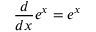<formula> <loc_0><loc_0><loc_500><loc_500>{ \frac { d } { d x } } e ^ { x } = e ^ { x }</formula> 